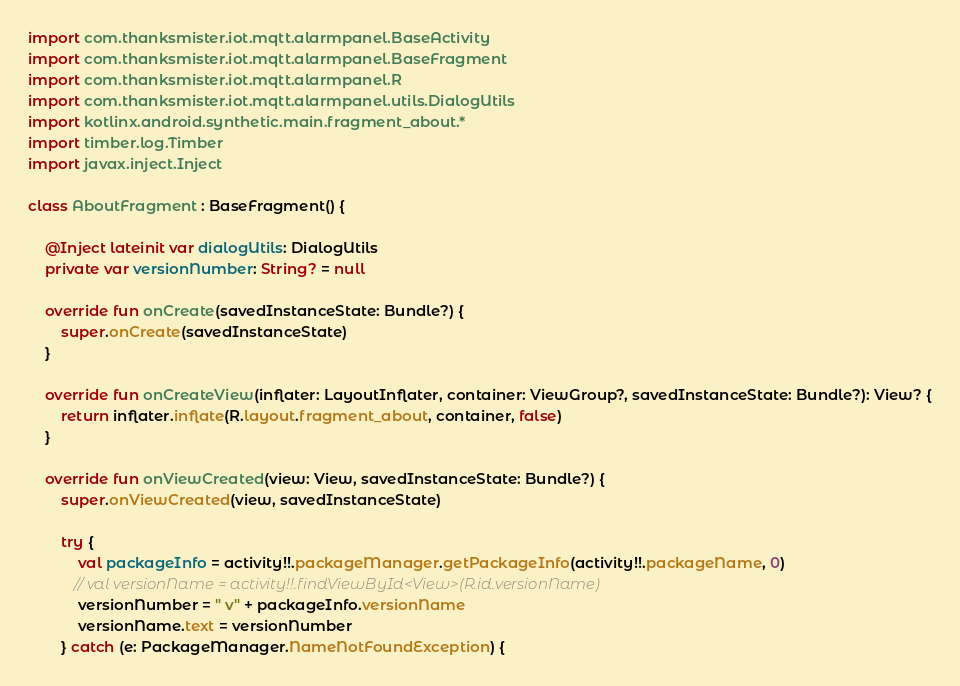Convert code to text. <code><loc_0><loc_0><loc_500><loc_500><_Kotlin_>import com.thanksmister.iot.mqtt.alarmpanel.BaseActivity
import com.thanksmister.iot.mqtt.alarmpanel.BaseFragment
import com.thanksmister.iot.mqtt.alarmpanel.R
import com.thanksmister.iot.mqtt.alarmpanel.utils.DialogUtils
import kotlinx.android.synthetic.main.fragment_about.*
import timber.log.Timber
import javax.inject.Inject

class AboutFragment : BaseFragment() {

    @Inject lateinit var dialogUtils: DialogUtils
    private var versionNumber: String? = null

    override fun onCreate(savedInstanceState: Bundle?) {
        super.onCreate(savedInstanceState)
    }

    override fun onCreateView(inflater: LayoutInflater, container: ViewGroup?, savedInstanceState: Bundle?): View? {
        return inflater.inflate(R.layout.fragment_about, container, false)
    }

    override fun onViewCreated(view: View, savedInstanceState: Bundle?) {
        super.onViewCreated(view, savedInstanceState)

        try {
            val packageInfo = activity!!.packageManager.getPackageInfo(activity!!.packageName, 0)
           // val versionName = activity!!.findViewById<View>(R.id.versionName)
            versionNumber = " v" + packageInfo.versionName
            versionName.text = versionNumber
        } catch (e: PackageManager.NameNotFoundException) {</code> 